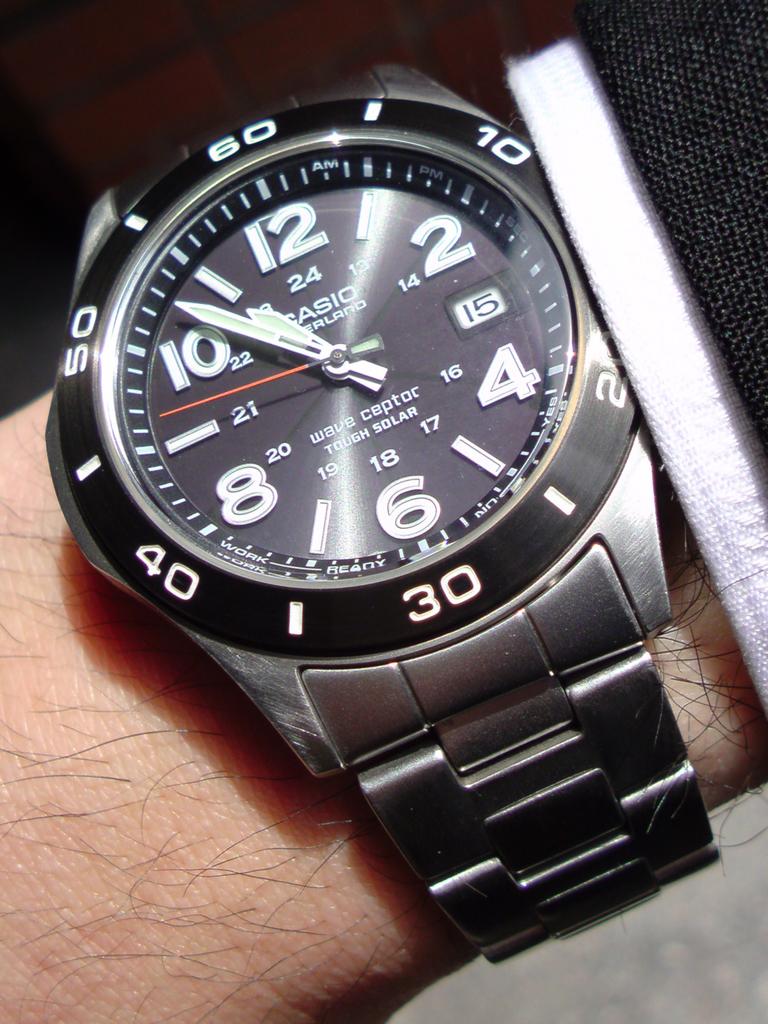What brand of watch is this?
Ensure brevity in your answer.  Casio. 